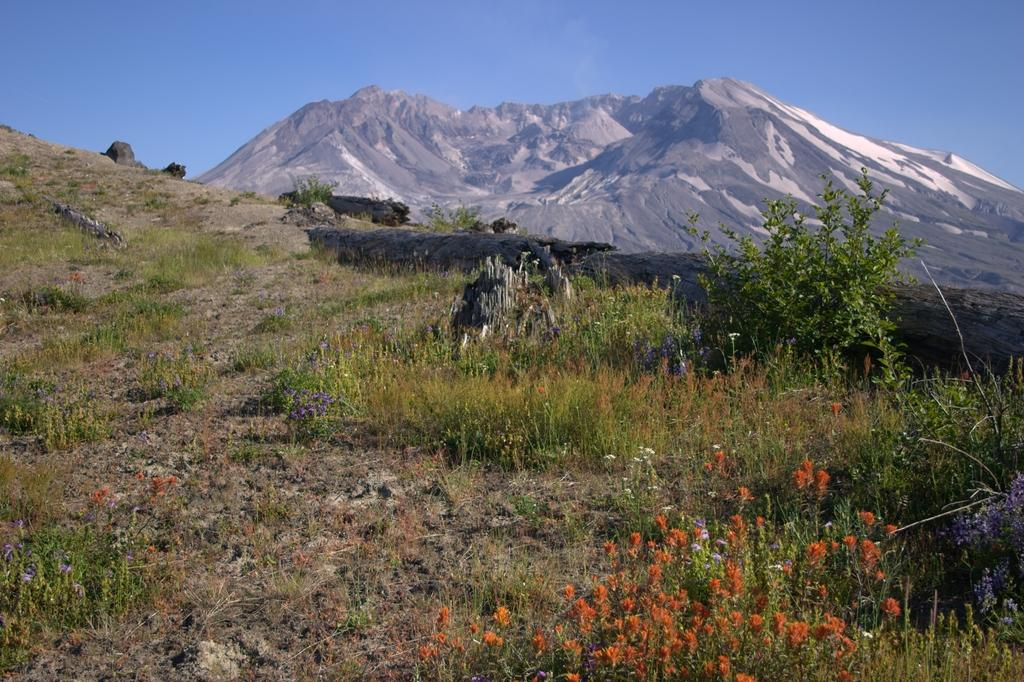Where was the picture taken? The picture was clicked outside. What can be seen in the center of the image? There are plants and grass in the center of the image. What is visible in the background of the image? There is a sky and hills visible in the background of the image, along with other objects. What is the authority's opinion on the tendency of things in the image? There is no authority or opinion mentioned in the image, as it only contains a scene with plants, grass, sky, hills, and other objects. 